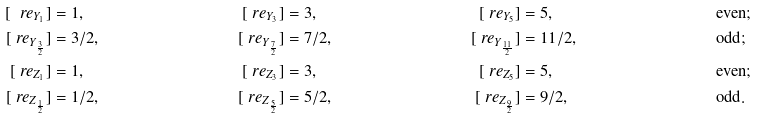<formula> <loc_0><loc_0><loc_500><loc_500>[ \ r e _ { Y _ { 1 } } ] & = 1 , & [ \ r e _ { Y _ { 3 } } ] & = 3 , & [ \ r e _ { Y _ { 5 } } ] & = 5 , & & \text {even} ; \\ [ \ r e _ { Y _ { \frac { 3 } { 2 } } } ] & = { 3 } / { 2 } , & [ \ r e _ { Y _ { \frac { 7 } { 2 } } } ] & = { 7 } / { 2 } , & [ \ r e _ { Y _ { \frac { 1 1 } { 2 } } } ] & = { 1 1 } / { 2 } , & & \text {odd} ; \\ [ \ r e _ { Z _ { 1 } } ] & = 1 , & [ \ r e _ { Z _ { 3 } } ] & = 3 , & [ \ r e _ { Z _ { 5 } } ] & = 5 , & & \text {even} ; \\ [ \ r e _ { Z _ { \frac { 1 } { 2 } } } ] & = { 1 } / { 2 } , & [ \ r e _ { Z _ { \frac { 5 } { 2 } } } ] & = { 5 } / { 2 } , & [ \ r e _ { Z _ { \frac { 9 } { 2 } } } ] & = { 9 } / { 2 } , & & \text {odd} .</formula> 